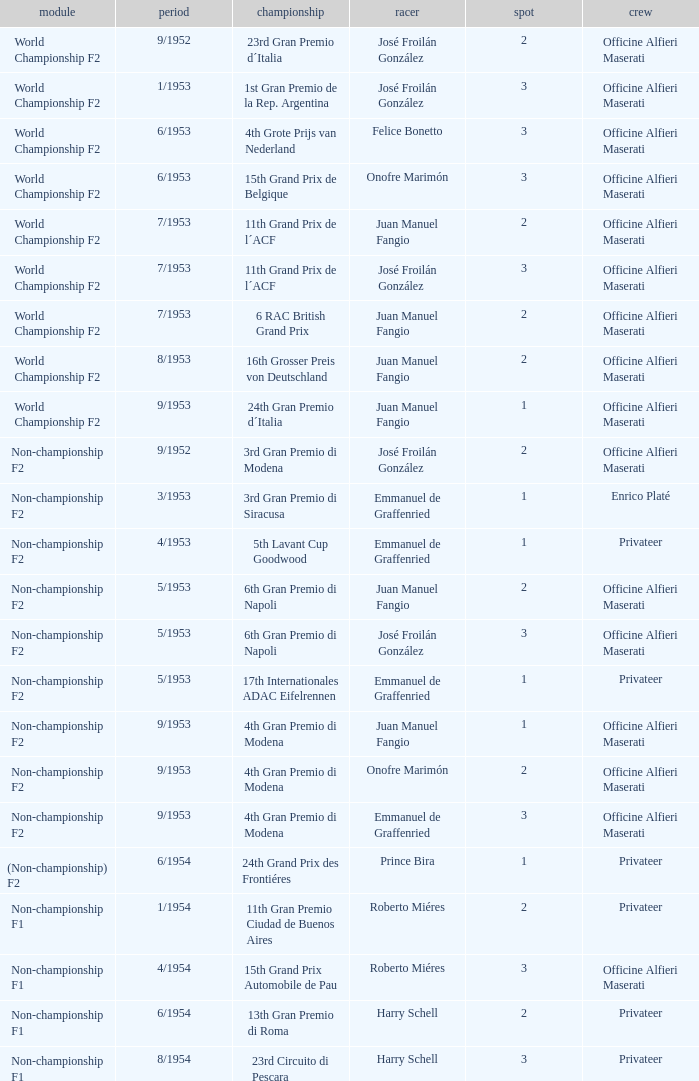What driver has a team of officine alfieri maserati and belongs to the class of non-championship f2 and has a position of 2, as well as a date of 9/1952? José Froilán González. 